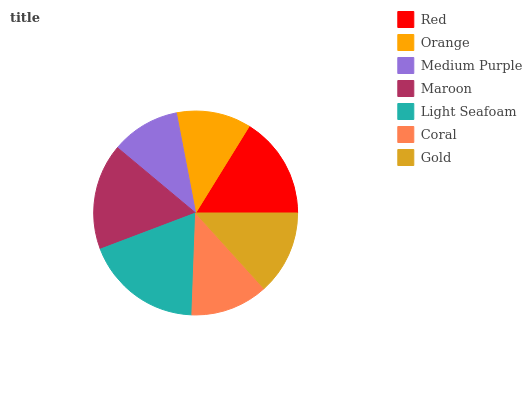Is Medium Purple the minimum?
Answer yes or no. Yes. Is Light Seafoam the maximum?
Answer yes or no. Yes. Is Orange the minimum?
Answer yes or no. No. Is Orange the maximum?
Answer yes or no. No. Is Red greater than Orange?
Answer yes or no. Yes. Is Orange less than Red?
Answer yes or no. Yes. Is Orange greater than Red?
Answer yes or no. No. Is Red less than Orange?
Answer yes or no. No. Is Gold the high median?
Answer yes or no. Yes. Is Gold the low median?
Answer yes or no. Yes. Is Orange the high median?
Answer yes or no. No. Is Maroon the low median?
Answer yes or no. No. 